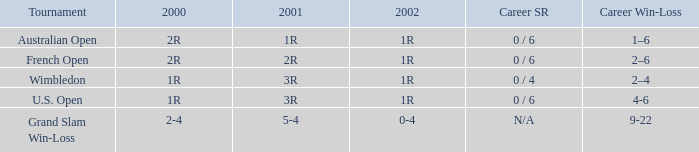Which career win-loss record has a 1r in 2002, a 2r in 2000 and a 2r in 2001? 2–6. 